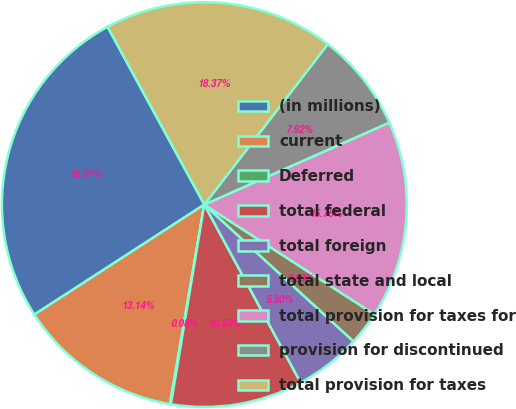Convert chart. <chart><loc_0><loc_0><loc_500><loc_500><pie_chart><fcel>(in millions)<fcel>current<fcel>Deferred<fcel>total federal<fcel>total foreign<fcel>total state and local<fcel>total provision for taxes for<fcel>provision for discontinued<fcel>total provision for taxes<nl><fcel>26.21%<fcel>13.14%<fcel>0.08%<fcel>10.53%<fcel>5.3%<fcel>2.69%<fcel>15.76%<fcel>7.92%<fcel>18.37%<nl></chart> 